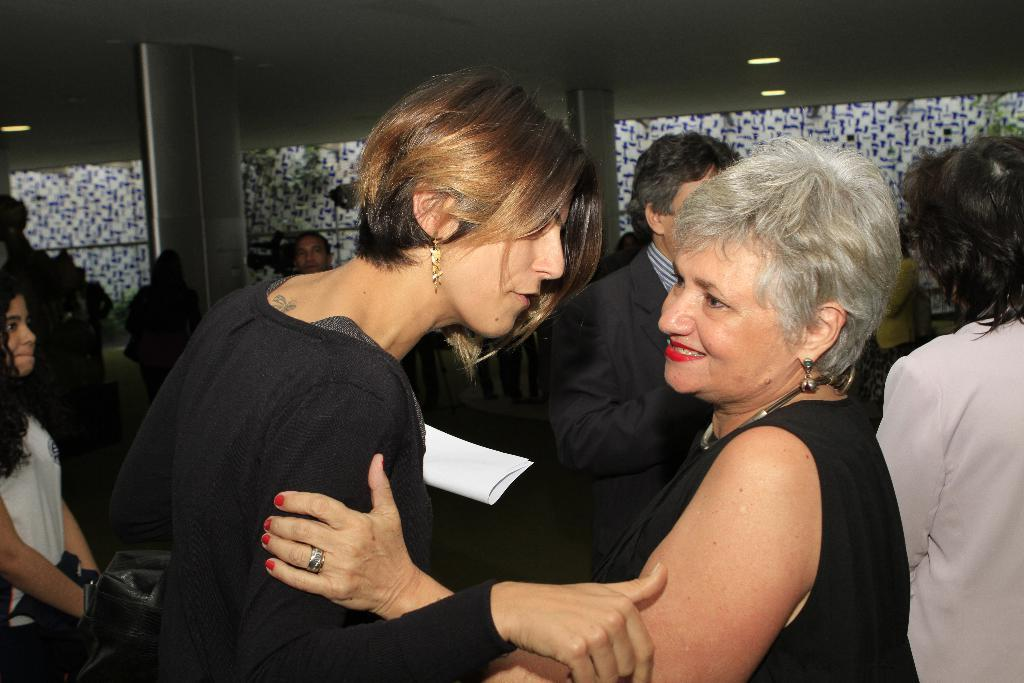What is the setting of the image? The image shows many people in a hall. What can be seen on the ceiling of the hall? There are lights on the ceiling. Can you describe the two ladies in the foreground? The two ladies in the foreground are standing, and they are both wearing black dresses. What type of teeth can be seen in the image? There are no teeth visible in the image; it features people in a hall with lights on the ceiling and two ladies wearing black dresses. 